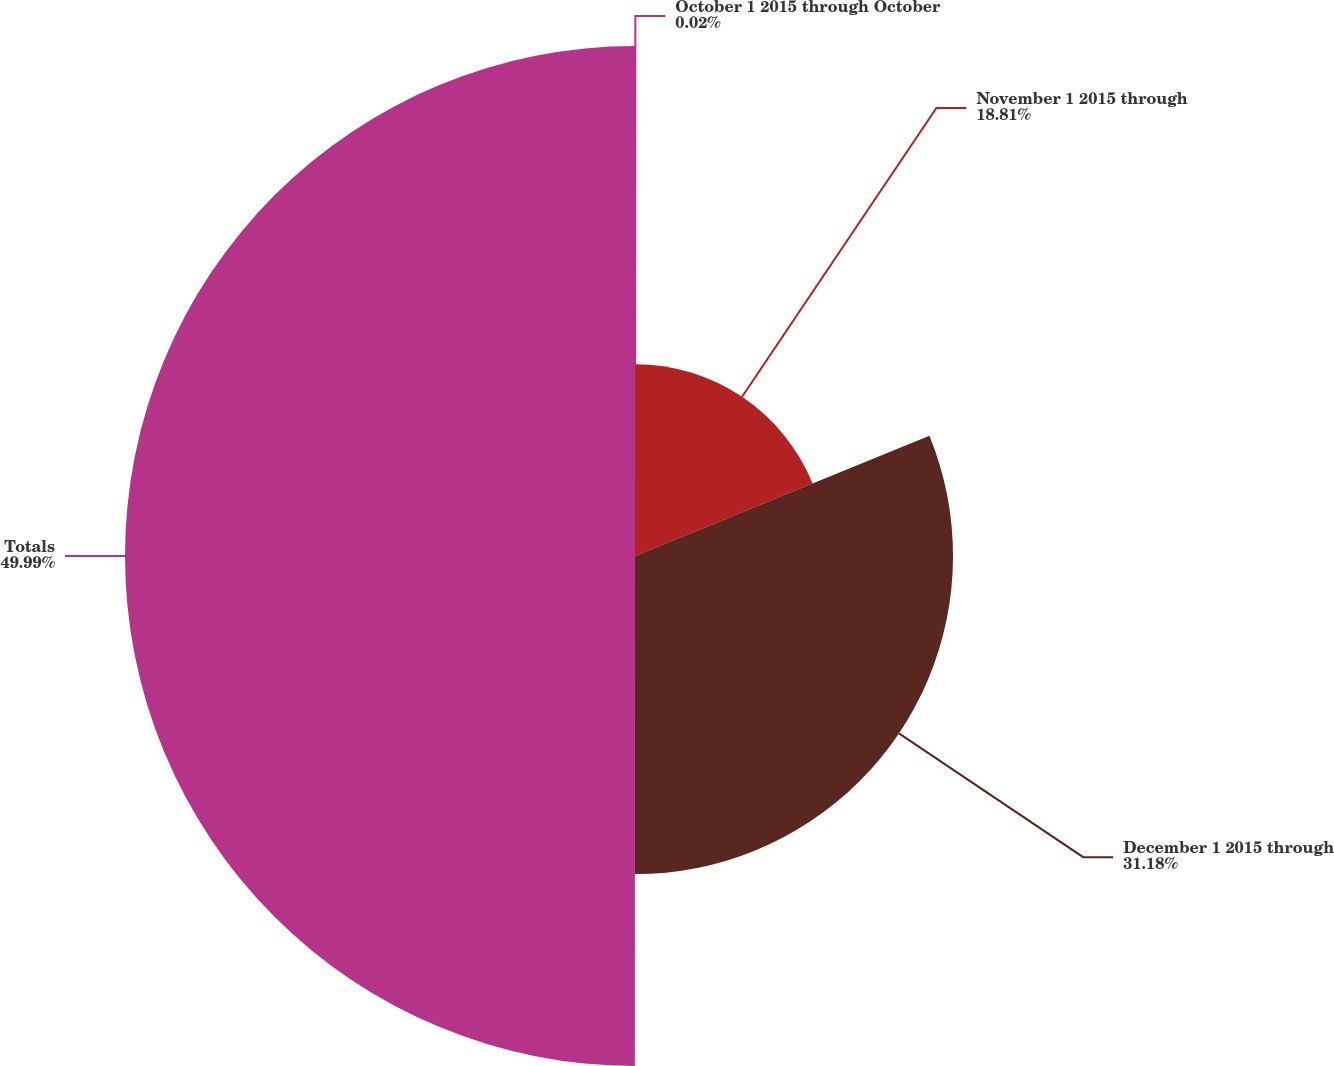Convert chart to OTSL. <chart><loc_0><loc_0><loc_500><loc_500><pie_chart><fcel>October 1 2015 through October<fcel>November 1 2015 through<fcel>December 1 2015 through<fcel>Totals<nl><fcel>0.02%<fcel>18.81%<fcel>31.18%<fcel>50.0%<nl></chart> 